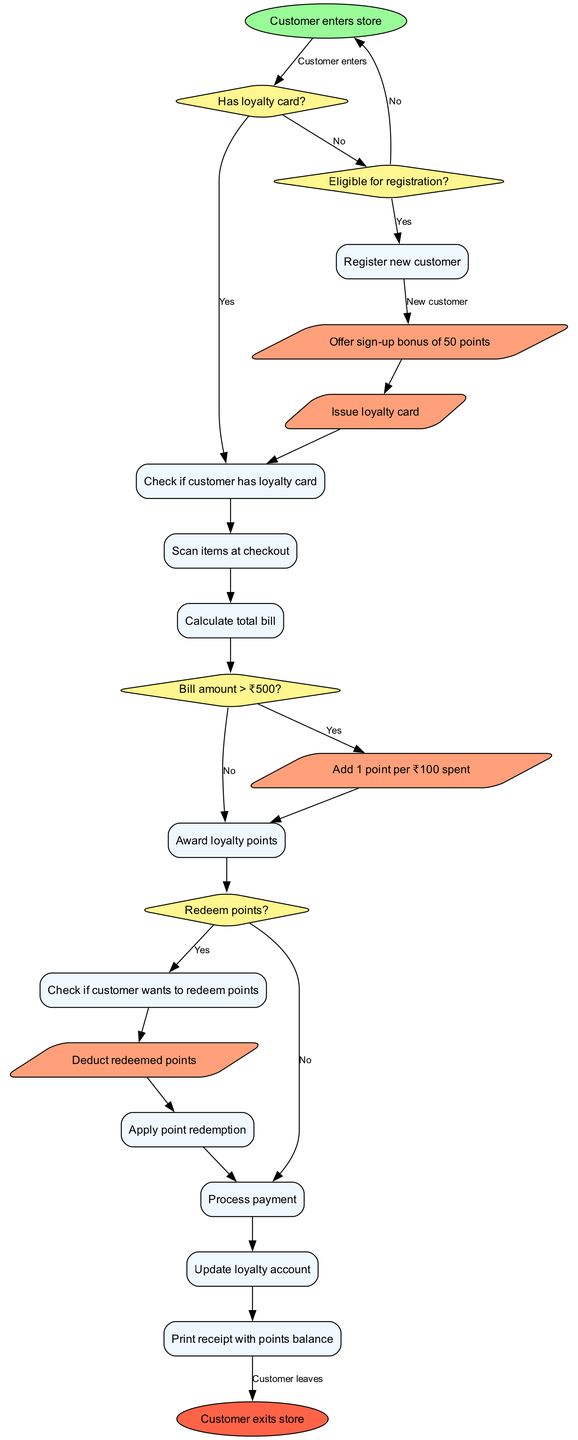What is the starting point of the workflow? The workflow begins with the "Customer enters store" node, which is the first action in the flowchart.
Answer: Customer enters store How many decision nodes are there in the diagram? The diagram contains four decision nodes: "Has loyalty card?", "Eligible for registration?", "Bill amount > ₹500?", and "Redeem points?". Therefore, the total number is four.
Answer: 4 What action occurs if the customer does not have a loyalty card? If the customer does not have a loyalty card, the flow proceeds to the action node "Issue loyalty card" after the decision node "Has loyalty card?" indicates "No".
Answer: Issue loyalty card What happens after checking if the bill amount is greater than ₹500? If the bill amount exceeds ₹500, the flow continues to award loyalty points through the action node "Add 1 point per ₹100 spent". If not, it moves directly to processing payment.
Answer: Add 1 point per ₹100 spent What is the end point of the workflow? The workflow concludes with the "Customer exits store" node, marking the completion of the customer process in the loyalty program.
Answer: Customer exits store What action is taken when a customer chooses to redeem points? When a customer chooses to redeem points, the flow leads to the action node "Deduct redeemed points", indicating the points are deducted from their loyalty account.
Answer: Deduct redeemed points What node follows after "Scan items at checkout"? After the node "Scan items at checkout", the flow moves on to "Calculate total bill", indicating the next step in the checkout process.
Answer: Calculate total bill What does the flowchart offer for new customers? The flowchart includes an action to "Offer sign-up bonus of 50 points" specifically for new customers, encouraging registration in the loyalty program.
Answer: Offer sign-up bonus of 50 points 